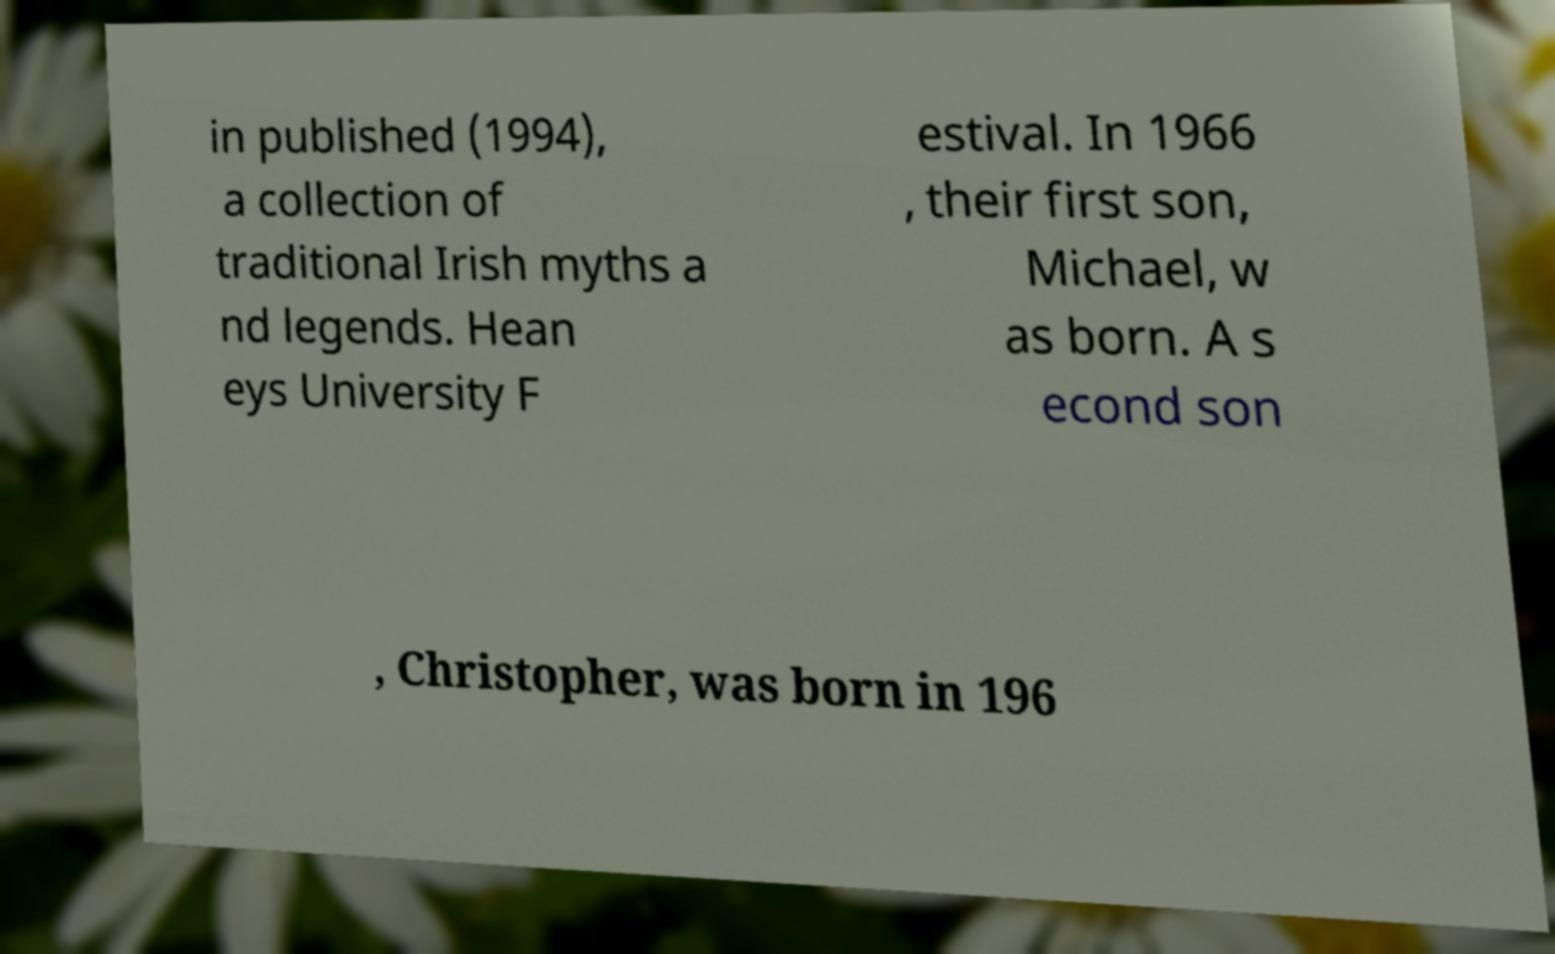For documentation purposes, I need the text within this image transcribed. Could you provide that? in published (1994), a collection of traditional Irish myths a nd legends. Hean eys University F estival. In 1966 , their first son, Michael, w as born. A s econd son , Christopher, was born in 196 